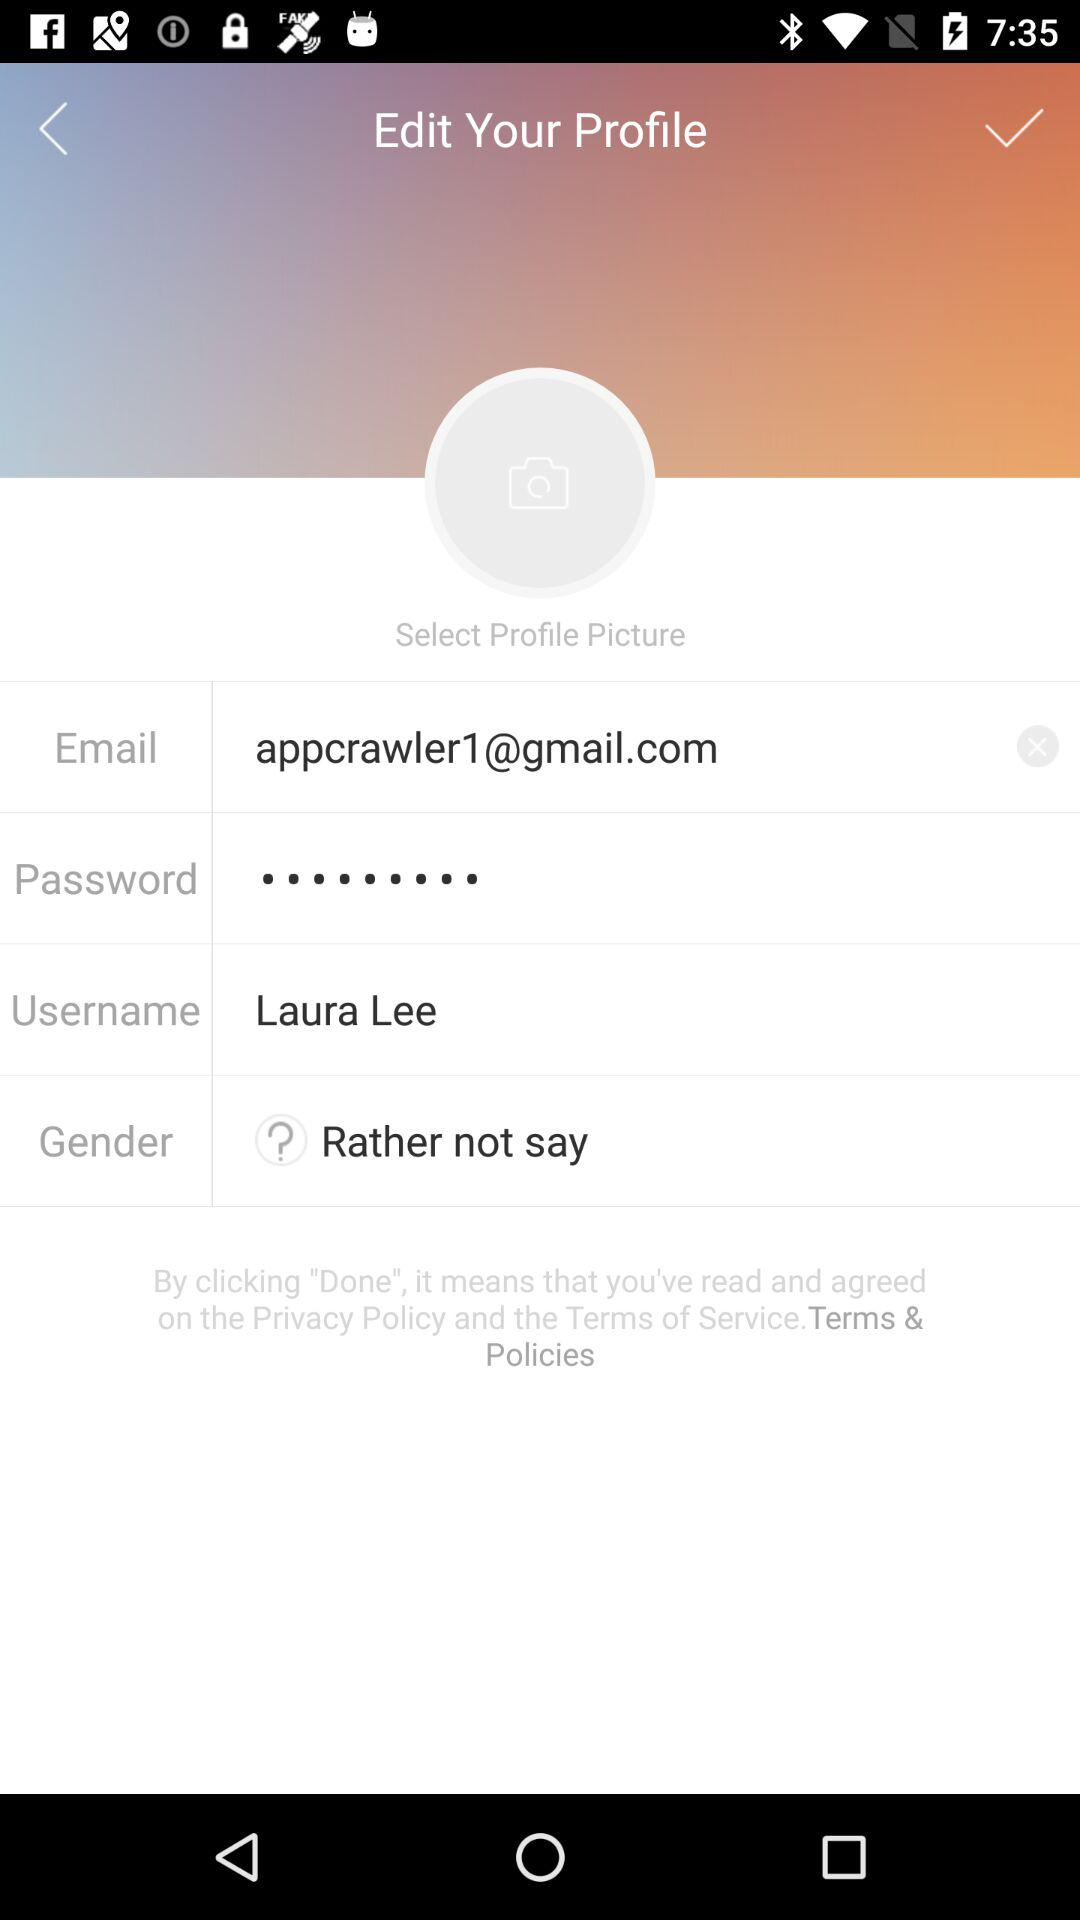What is the selected gender?
Answer the question using a single word or phrase. The selected gender is "Rather not say", 